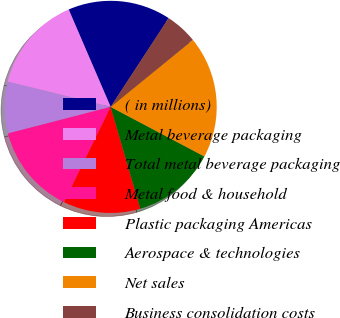Convert chart. <chart><loc_0><loc_0><loc_500><loc_500><pie_chart><fcel>( in millions)<fcel>Metal beverage packaging<fcel>Total metal beverage packaging<fcel>Metal food & household<fcel>Plastic packaging Americas<fcel>Aerospace & technologies<fcel>Net sales<fcel>Business consolidation costs<nl><fcel>15.69%<fcel>14.71%<fcel>7.84%<fcel>13.73%<fcel>11.76%<fcel>12.75%<fcel>18.63%<fcel>4.9%<nl></chart> 